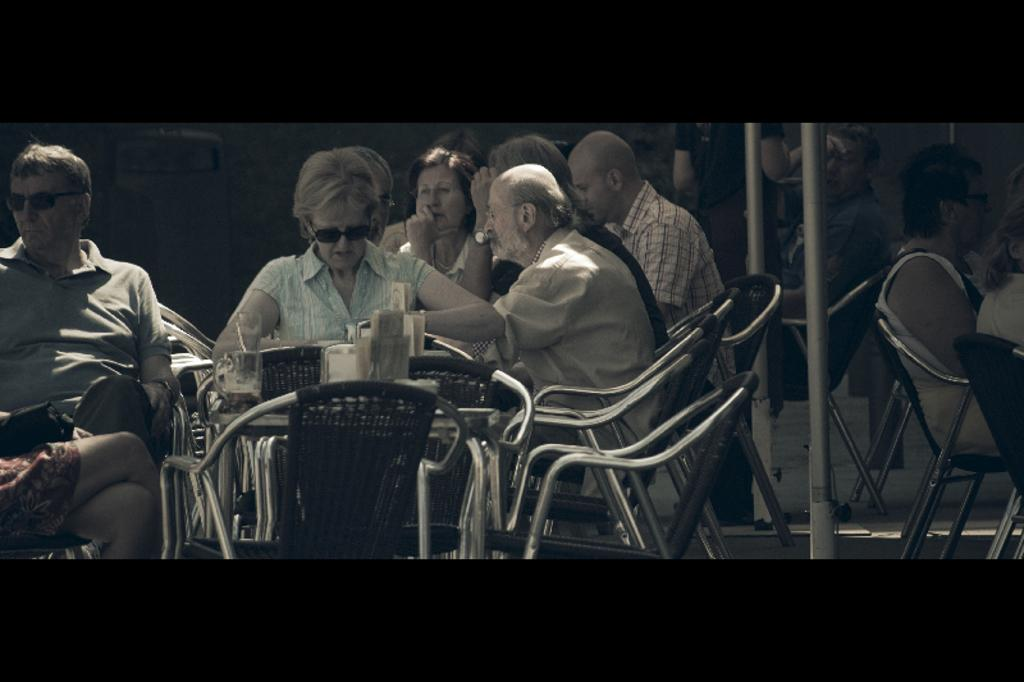What are most of the persons in the image doing? Most persons are sitting on chairs. What can be seen on the table in the image? There is a glass with liquid on a table. What objects are present in the image that resemble long, thin structures? There are poles in the image. Can you describe the position of one person in relation to the others? A person is standing far from the others. What type of protective eyewear is being worn by some persons in the image? Two persons are wearing goggles. What type of alarm is being triggered by the ink in the image? There is no alarm or ink present in the image. 